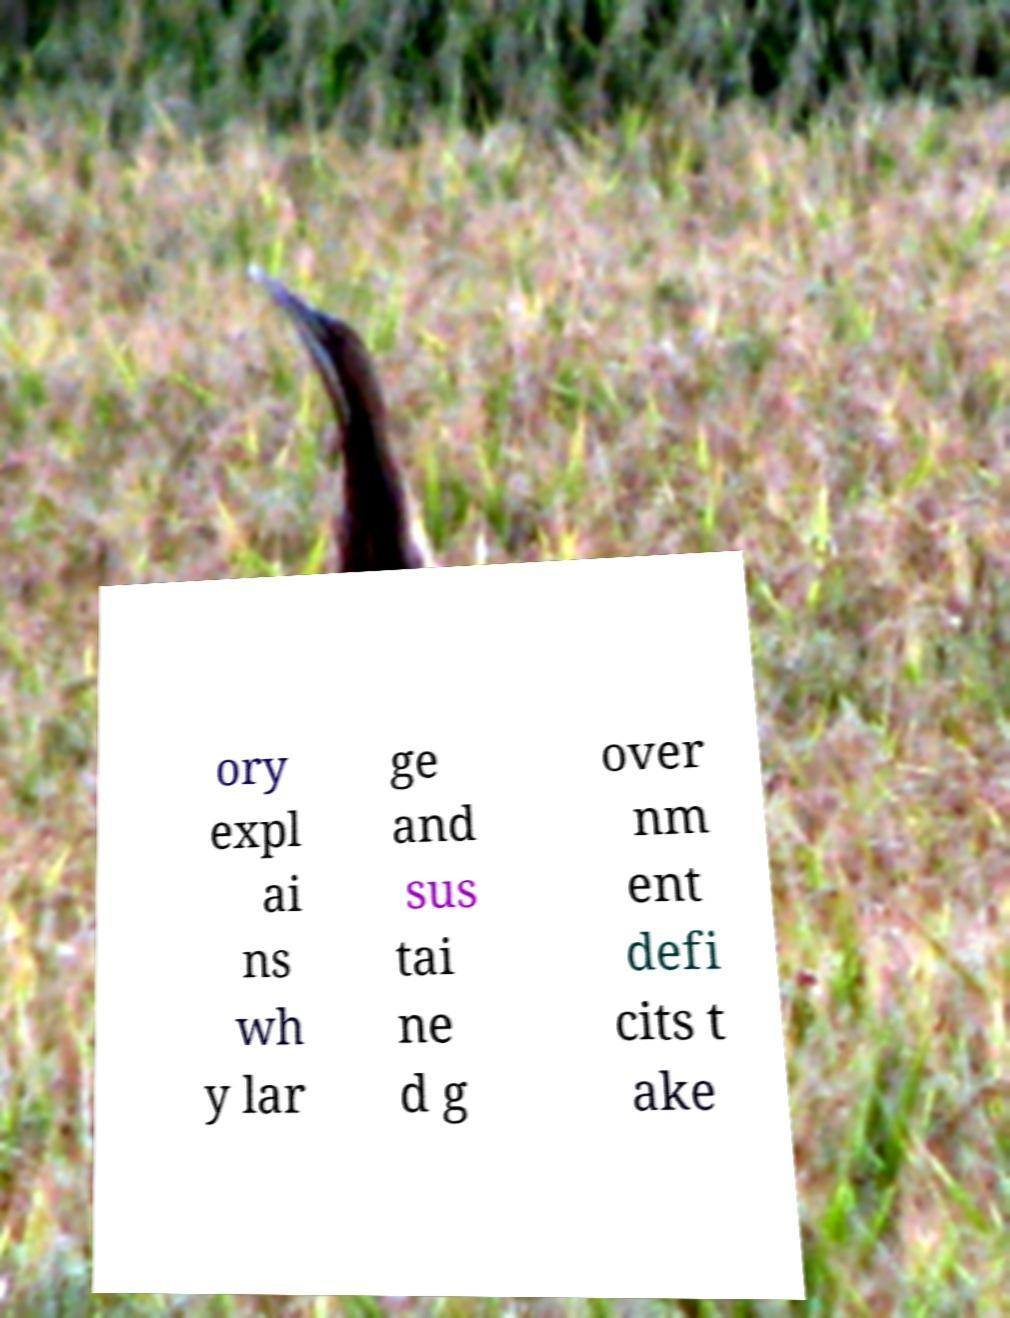What messages or text are displayed in this image? I need them in a readable, typed format. ory expl ai ns wh y lar ge and sus tai ne d g over nm ent defi cits t ake 